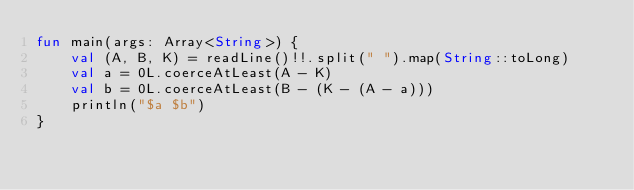Convert code to text. <code><loc_0><loc_0><loc_500><loc_500><_Kotlin_>fun main(args: Array<String>) {
    val (A, B, K) = readLine()!!.split(" ").map(String::toLong)
    val a = 0L.coerceAtLeast(A - K)
    val b = 0L.coerceAtLeast(B - (K - (A - a)))
    println("$a $b")
}</code> 